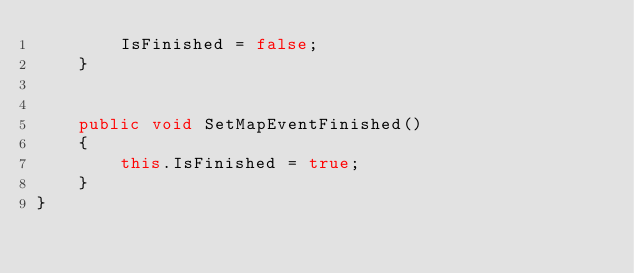<code> <loc_0><loc_0><loc_500><loc_500><_C#_>		IsFinished = false;
	}


    public void SetMapEventFinished()
    {
        this.IsFinished = true;
    }
}</code> 